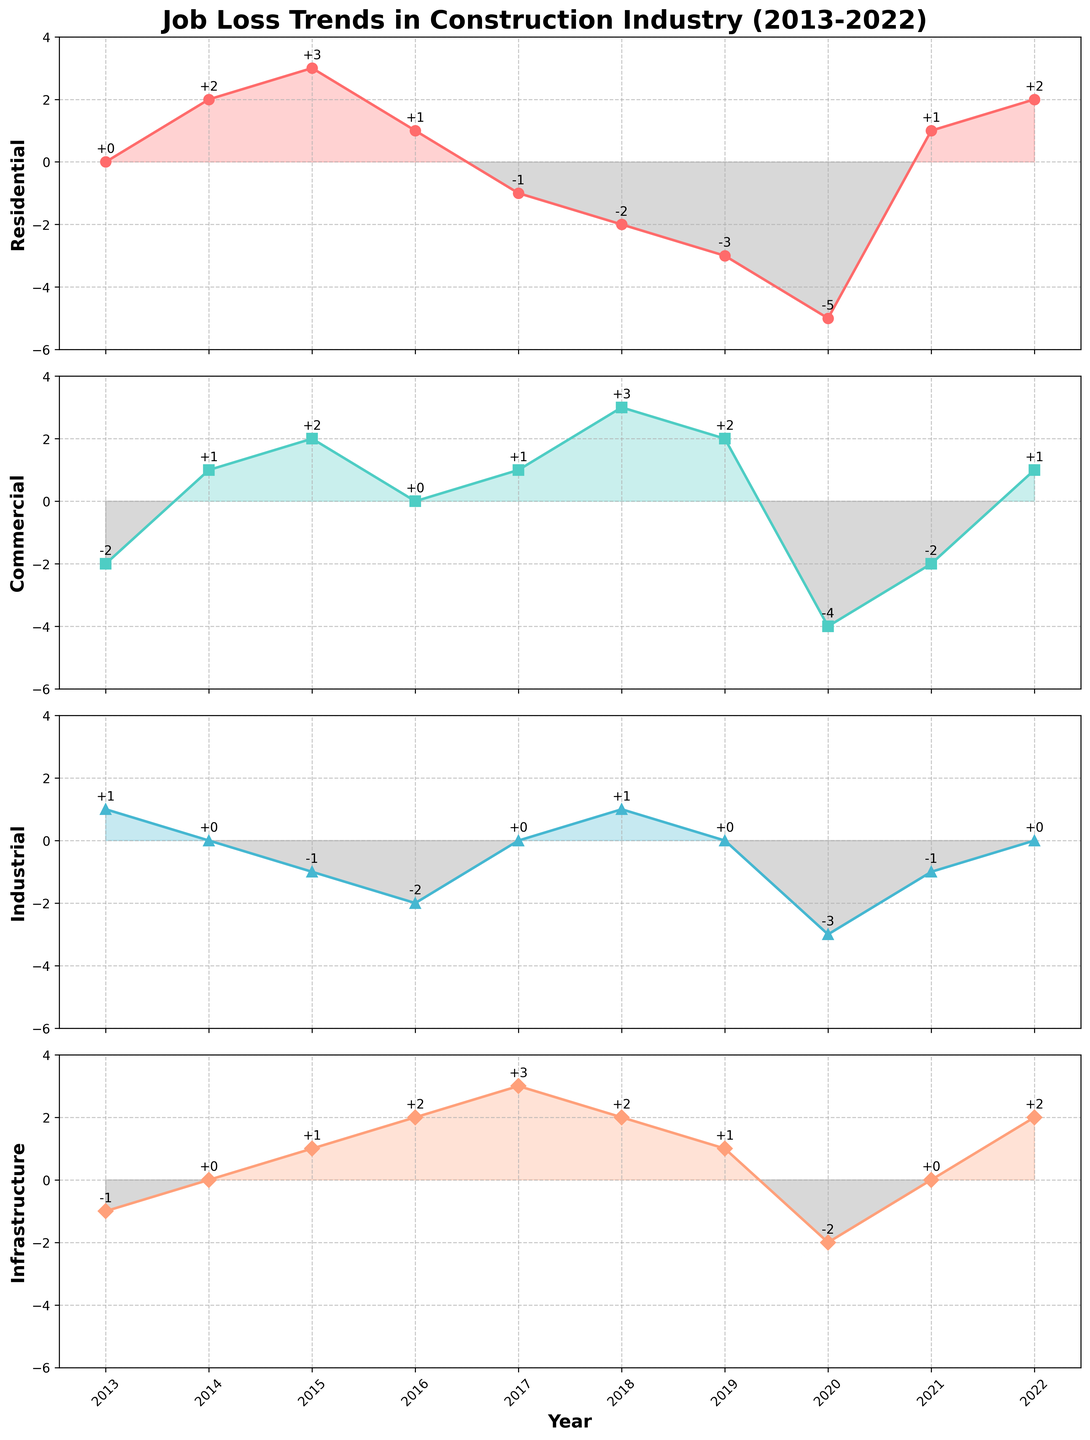How many sectors show a negative job loss in 2020? In 2020, examine the data values for all four sectors (Residential, Commercial, Industrial, Infrastructure). All values are negative for each sector.
Answer: 4 Which sector experienced the highest job loss in 2020? Look at the job loss values for each sector in 2020. Residential has the lowest value at -5, indicating the highest job loss.
Answer: Residential Which year did the Infrastructure sector see the most significant job gain? Identify the highest positive value for the Infrastructure sector across the years. The year 2017 has the highest value of 3.
Answer: 2017 How did the Commercial sector perform in 2018 compared to 2020? The job gain/loss for the Commercial sector is +3 in 2018 and -4 in 2020. Compare these two values to determine the better performance.
Answer: Better in 2018 What was the average job loss/gain in the Industrial sector over the decade? Sum the Industrial sector values from 2013 to 2022 and then divide by the number of years (10). The sum is -4, so the average is -4 / 10 = -0.4.
Answer: -0.4 Which year had the largest total job gain across all sectors? For each year, sum the job gain/loss values across all sectors and identify the year with the highest total. 2017 has the highest total with (−1 + 1 + 0 + 3) = 3.
Answer: 2017 Were there any years when all sectors experienced positive job gains? Check each year to see if all sector values are positive. No year had all positive values; there's always at least one sector with a non-positive number.
Answer: No Which sector showed the most consistent performance over the decade? Examine variability in job gain/loss values for each sector. Infrastructure had the least extreme values ranging between -2 and +3, suggesting more consistency.
Answer: Infrastructure 